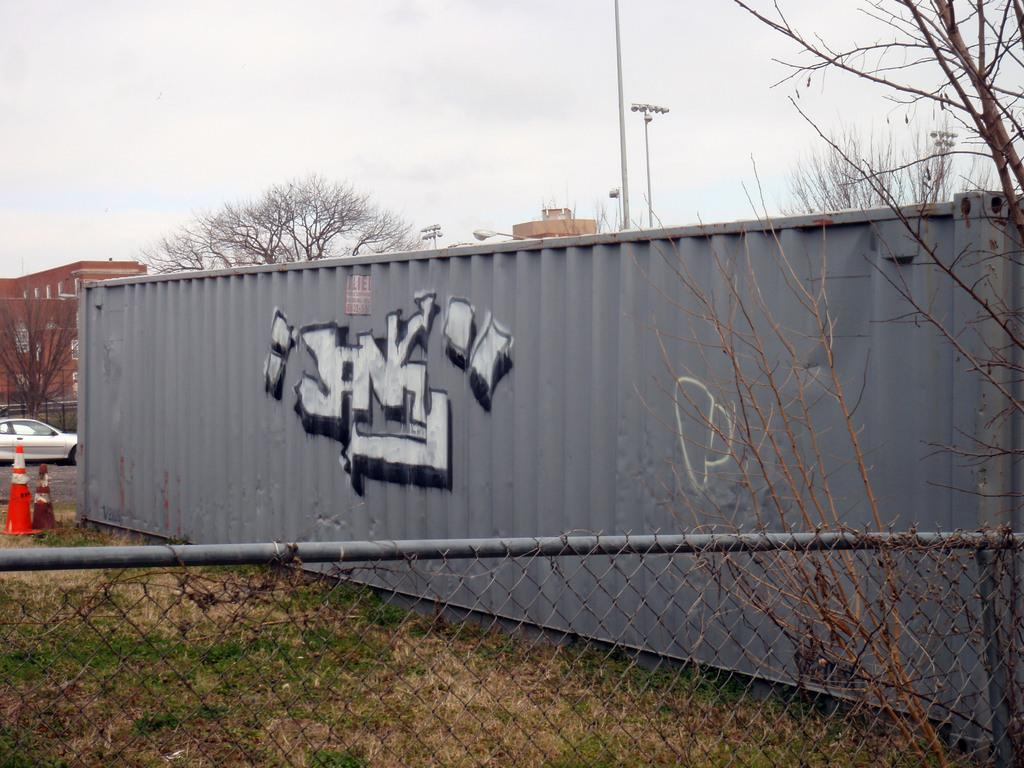<image>
Provide a brief description of the given image. A gray storage container with the words "JANK" graffiti on it. 